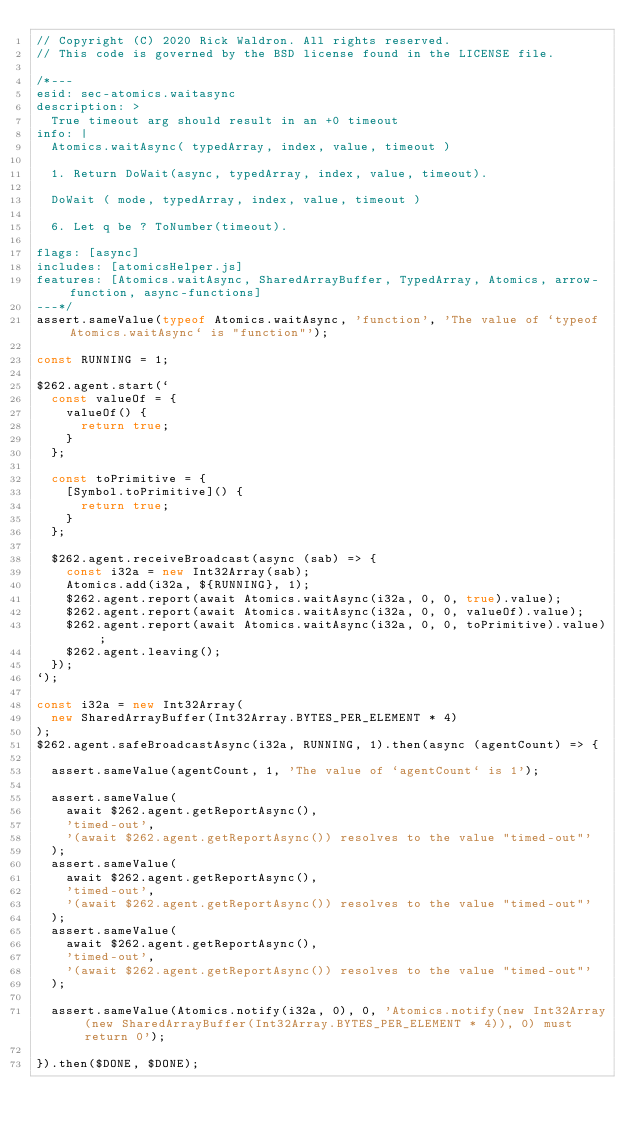<code> <loc_0><loc_0><loc_500><loc_500><_JavaScript_>// Copyright (C) 2020 Rick Waldron. All rights reserved.
// This code is governed by the BSD license found in the LICENSE file.

/*---
esid: sec-atomics.waitasync
description: >
  True timeout arg should result in an +0 timeout
info: |
  Atomics.waitAsync( typedArray, index, value, timeout )

  1. Return DoWait(async, typedArray, index, value, timeout).

  DoWait ( mode, typedArray, index, value, timeout )

  6. Let q be ? ToNumber(timeout).

flags: [async]
includes: [atomicsHelper.js]
features: [Atomics.waitAsync, SharedArrayBuffer, TypedArray, Atomics, arrow-function, async-functions]
---*/
assert.sameValue(typeof Atomics.waitAsync, 'function', 'The value of `typeof Atomics.waitAsync` is "function"');

const RUNNING = 1;

$262.agent.start(`
  const valueOf = {
    valueOf() {
      return true;
    }
  };

  const toPrimitive = {
    [Symbol.toPrimitive]() {
      return true;
    }
  };

  $262.agent.receiveBroadcast(async (sab) => {
    const i32a = new Int32Array(sab);
    Atomics.add(i32a, ${RUNNING}, 1);
    $262.agent.report(await Atomics.waitAsync(i32a, 0, 0, true).value);
    $262.agent.report(await Atomics.waitAsync(i32a, 0, 0, valueOf).value);
    $262.agent.report(await Atomics.waitAsync(i32a, 0, 0, toPrimitive).value);
    $262.agent.leaving();
  });
`);

const i32a = new Int32Array(
  new SharedArrayBuffer(Int32Array.BYTES_PER_ELEMENT * 4)
);
$262.agent.safeBroadcastAsync(i32a, RUNNING, 1).then(async (agentCount) => {

  assert.sameValue(agentCount, 1, 'The value of `agentCount` is 1');

  assert.sameValue(
    await $262.agent.getReportAsync(),
    'timed-out',
    '(await $262.agent.getReportAsync()) resolves to the value "timed-out"'
  );
  assert.sameValue(
    await $262.agent.getReportAsync(),
    'timed-out',
    '(await $262.agent.getReportAsync()) resolves to the value "timed-out"'
  );
  assert.sameValue(
    await $262.agent.getReportAsync(),
    'timed-out',
    '(await $262.agent.getReportAsync()) resolves to the value "timed-out"'
  );

  assert.sameValue(Atomics.notify(i32a, 0), 0, 'Atomics.notify(new Int32Array(new SharedArrayBuffer(Int32Array.BYTES_PER_ELEMENT * 4)), 0) must return 0');

}).then($DONE, $DONE);


</code> 